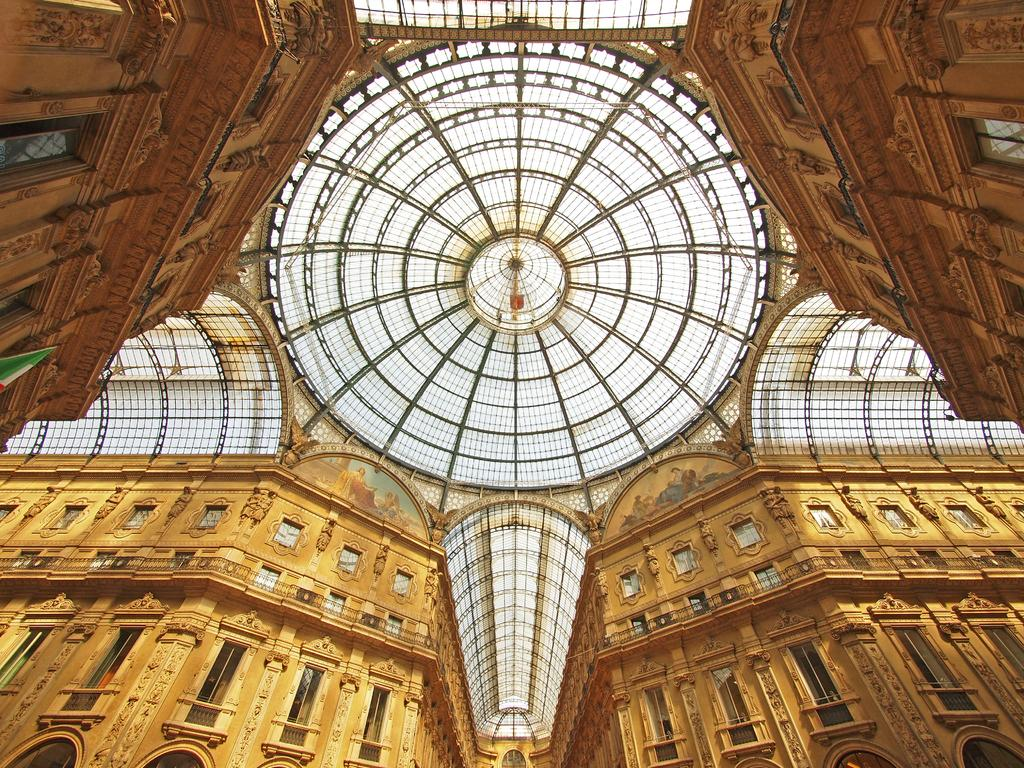What part of a building can be seen in the image? The image contains a roof. What else is visible in the background of the image? There are walls of a building visible in the background of the image. How do the houses in the image say good-bye to each other? There are no houses present in the image, and therefore they cannot say good-bye to each other. 